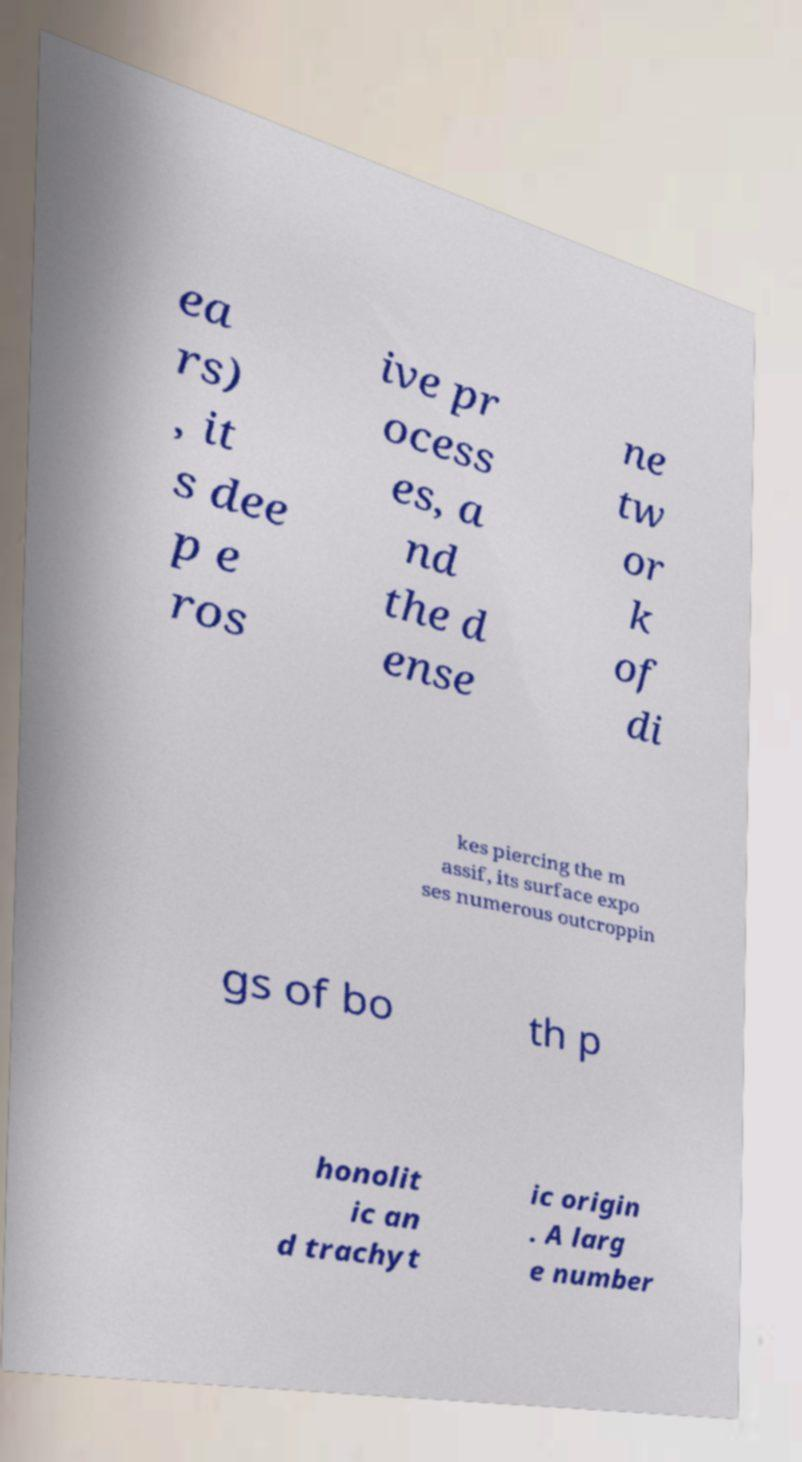Could you assist in decoding the text presented in this image and type it out clearly? ea rs) , it s dee p e ros ive pr ocess es, a nd the d ense ne tw or k of di kes piercing the m assif, its surface expo ses numerous outcroppin gs of bo th p honolit ic an d trachyt ic origin . A larg e number 